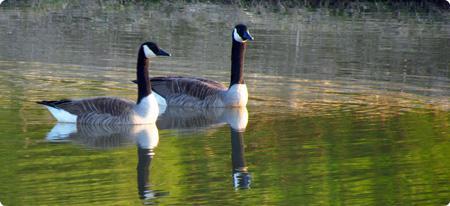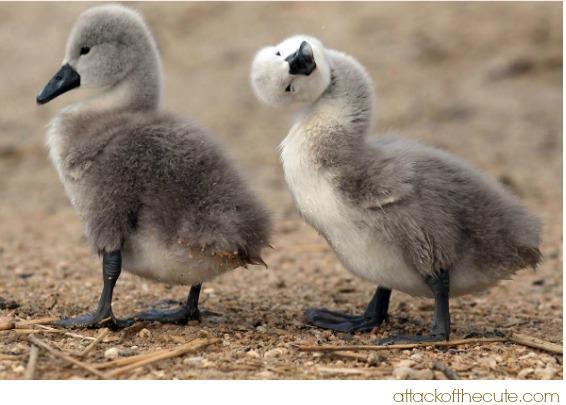The first image is the image on the left, the second image is the image on the right. Analyze the images presented: Is the assertion "Two geese are floating on the water in the image on the left." valid? Answer yes or no. Yes. 